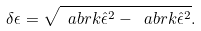<formula> <loc_0><loc_0><loc_500><loc_500>\delta \epsilon = \sqrt { \ a b r k { \hat { \epsilon } ^ { 2 } } - \ a b r k { \hat { \epsilon } } ^ { 2 } } .</formula> 